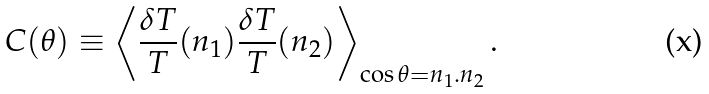<formula> <loc_0><loc_0><loc_500><loc_500>C ( \theta ) \equiv \left \langle \frac { \delta T } { T } ( { n } _ { 1 } ) \frac { \delta T } { T } ( { n } _ { 2 } ) \right \rangle _ { \cos \theta = { n } _ { 1 } . { n } _ { 2 } } .</formula> 